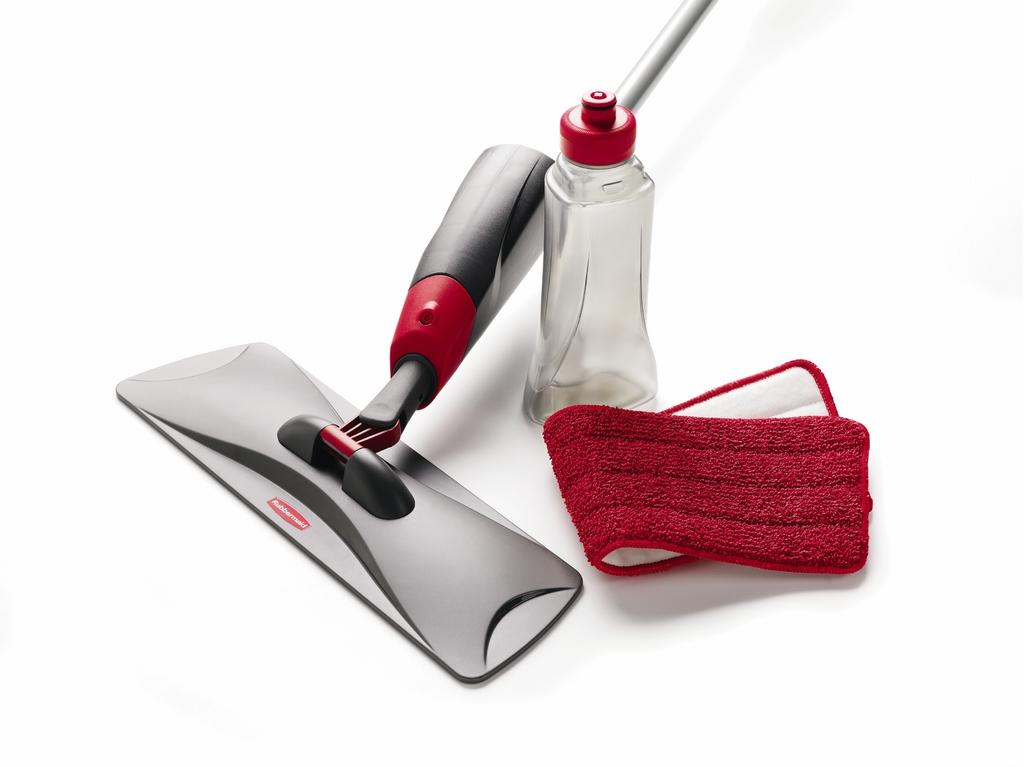What cleaning tool is featured in the image? There is a spray mop in the image. What type of container is present in the image? There is a bottle in the image. What material is used for cleaning in the image? There is a cloth in the image. Where can the needle be found in the image? There is no needle present in the image. Is there a fire visible in the image? There is no fire present in the image. 